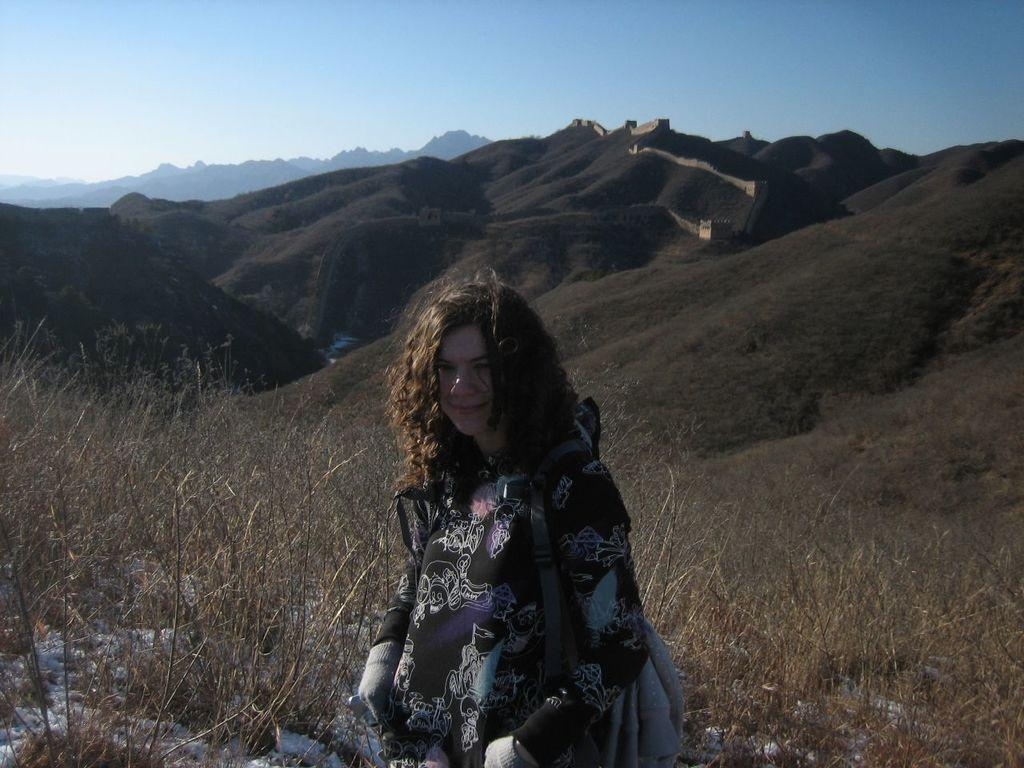Who is present in the image? There is a woman in the picture. What is the woman wearing? The woman is wearing a bag. What can be seen in the background of the image? Hills are visible in the background of the image. What type of vegetation is present on the hills? There are plants on the hills. What color is the woman's underwear in the image? There is no information about the woman's underwear in the image, as it is not visible or mentioned in the facts provided. 